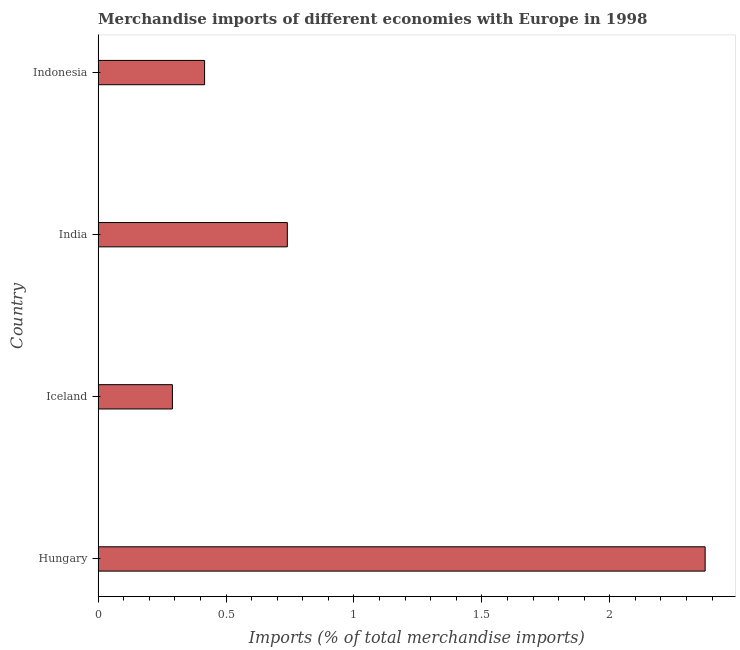Does the graph contain any zero values?
Your response must be concise. No. What is the title of the graph?
Provide a short and direct response. Merchandise imports of different economies with Europe in 1998. What is the label or title of the X-axis?
Offer a terse response. Imports (% of total merchandise imports). What is the label or title of the Y-axis?
Provide a succinct answer. Country. What is the merchandise imports in Indonesia?
Give a very brief answer. 0.42. Across all countries, what is the maximum merchandise imports?
Make the answer very short. 2.37. Across all countries, what is the minimum merchandise imports?
Give a very brief answer. 0.29. In which country was the merchandise imports maximum?
Give a very brief answer. Hungary. What is the sum of the merchandise imports?
Give a very brief answer. 3.82. What is the difference between the merchandise imports in Iceland and India?
Your response must be concise. -0.45. What is the average merchandise imports per country?
Give a very brief answer. 0.95. What is the median merchandise imports?
Your response must be concise. 0.58. What is the ratio of the merchandise imports in Iceland to that in Indonesia?
Ensure brevity in your answer.  0.7. Is the merchandise imports in Hungary less than that in Indonesia?
Keep it short and to the point. No. What is the difference between the highest and the second highest merchandise imports?
Give a very brief answer. 1.63. Is the sum of the merchandise imports in Iceland and India greater than the maximum merchandise imports across all countries?
Give a very brief answer. No. What is the difference between the highest and the lowest merchandise imports?
Your answer should be very brief. 2.08. How many bars are there?
Make the answer very short. 4. What is the difference between two consecutive major ticks on the X-axis?
Ensure brevity in your answer.  0.5. What is the Imports (% of total merchandise imports) of Hungary?
Offer a very short reply. 2.37. What is the Imports (% of total merchandise imports) of Iceland?
Offer a very short reply. 0.29. What is the Imports (% of total merchandise imports) in India?
Offer a terse response. 0.74. What is the Imports (% of total merchandise imports) of Indonesia?
Your response must be concise. 0.42. What is the difference between the Imports (% of total merchandise imports) in Hungary and Iceland?
Your answer should be compact. 2.08. What is the difference between the Imports (% of total merchandise imports) in Hungary and India?
Your response must be concise. 1.63. What is the difference between the Imports (% of total merchandise imports) in Hungary and Indonesia?
Offer a terse response. 1.96. What is the difference between the Imports (% of total merchandise imports) in Iceland and India?
Provide a succinct answer. -0.45. What is the difference between the Imports (% of total merchandise imports) in Iceland and Indonesia?
Ensure brevity in your answer.  -0.13. What is the difference between the Imports (% of total merchandise imports) in India and Indonesia?
Your response must be concise. 0.32. What is the ratio of the Imports (% of total merchandise imports) in Hungary to that in Iceland?
Ensure brevity in your answer.  8.17. What is the ratio of the Imports (% of total merchandise imports) in Hungary to that in India?
Ensure brevity in your answer.  3.21. What is the ratio of the Imports (% of total merchandise imports) in Hungary to that in Indonesia?
Your response must be concise. 5.7. What is the ratio of the Imports (% of total merchandise imports) in Iceland to that in India?
Ensure brevity in your answer.  0.39. What is the ratio of the Imports (% of total merchandise imports) in Iceland to that in Indonesia?
Provide a short and direct response. 0.7. What is the ratio of the Imports (% of total merchandise imports) in India to that in Indonesia?
Keep it short and to the point. 1.78. 